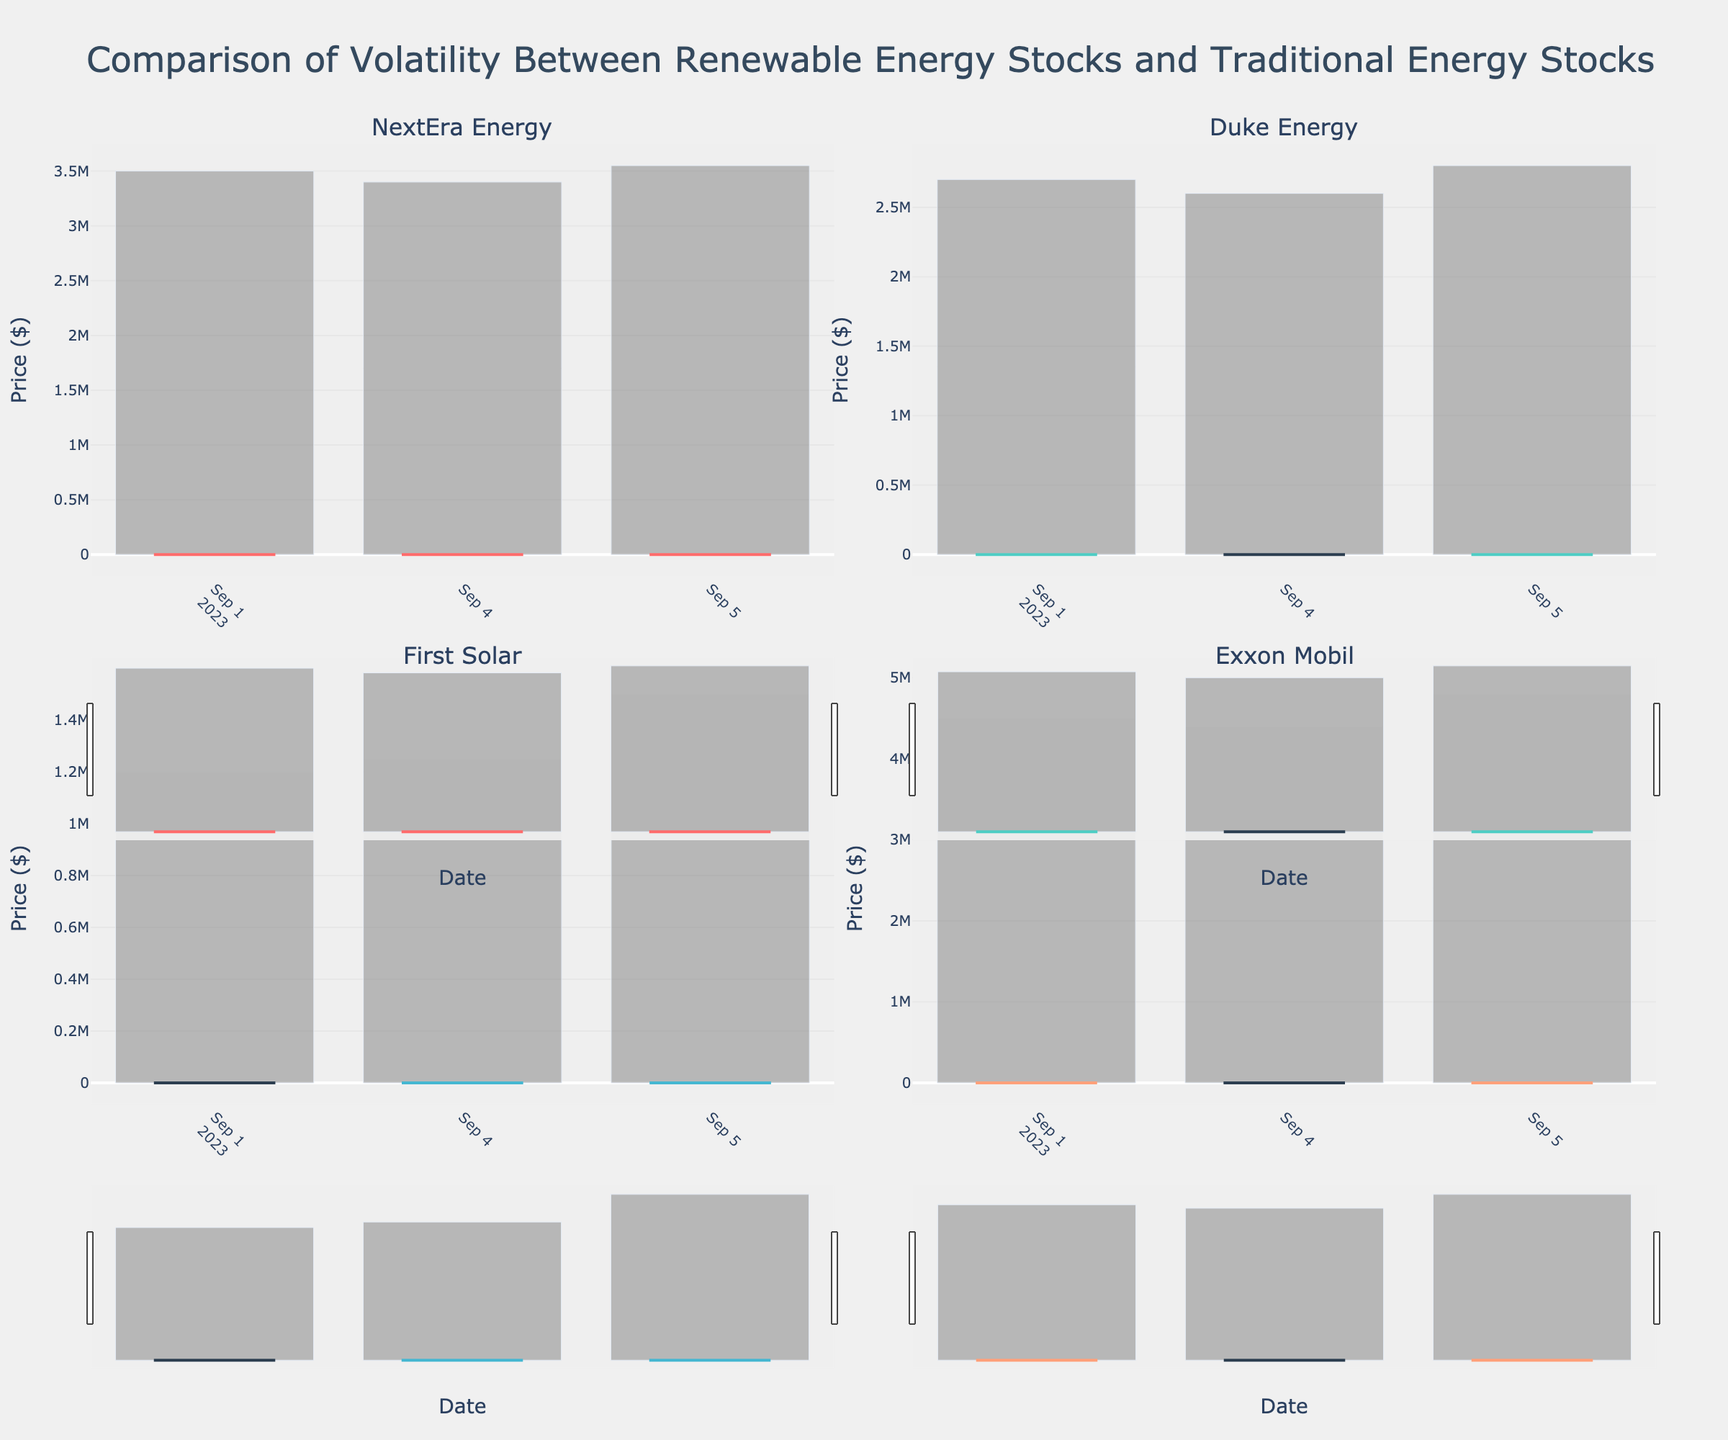Which stock has the highest closing price on September 1? On September 1, compare the closing prices of all four stocks. First Solar has the highest closing price of $189.00
Answer: First Solar How does the volatility of NextEra Energy compare to Duke Energy over the given period? Volatility can be assessed by examining the range between the high and low prices for each day. NextEra Energy has a higher daily price range compared to Duke Energy over the period, implying more volatility
Answer: NextEra Energy has more volatility How does the trading volume of Exxon Mobil on September 2 compare to that on September 3? Examine the volume bars for Exxon Mobil on these dates. On September 2, the volume is higher at 4,700,000 compared to 4,600,000 on September 3
Answer: September 2 has a higher volume What is the average closing price of First Solar over the given period? Sum the closing prices for First Solar for all days and divide by the number of days: (189.00 + 190.70 + 189.50 + 189.80 + 190.40) / 5 = 189.88
Answer: 189.88 Which stock shows the least price fluctuation between its high and low on September 5? Calculate the difference between the high and low for each stock on September 5. Duke Energy shows the smallest difference, with a range of $1.20 ($96.60 - $95.40)
Answer: Duke Energy What is the trend of NextEra Energy's closing prices over the given period? Observe the closing price points for NextEra Energy. The trend shows slight fluctuation but generally stabilizes around the $82-$83 range
Answer: Stable around $82-$83 Is there a day when all stocks show a decrease in their closing price compared to the previous day? Analyze the closing prices day-by-day. On September 3, all stocks show a decrease in their closing price compared to September 2
Answer: September 3 How does the closing price of Exxon Mobil on September 5 compare to that on September 1? Compare the closing prices of Exxon Mobil on these dates. On September 5, it is $116.80, which is higher than $115.60 on September 1
Answer: Higher on September 5 What is the overall trend in trading volume for Duke Energy over the period? Analyze the volume bars for Duke Energy. The volume shows slight fluctuations but is relatively stable, ranging between 2,400,000 and 2,800,000
Answer: Relatively stable How many times does First Solar have a closing price higher than its opening price over the period? Compare each day's closing price to its opening price for First Solar. First Solar ends higher than its opening price on three days (September 2, September 4, September 5)
Answer: Three times 